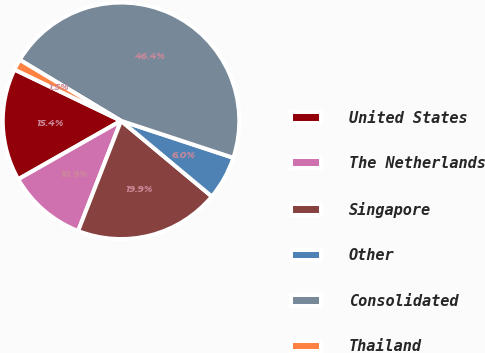<chart> <loc_0><loc_0><loc_500><loc_500><pie_chart><fcel>United States<fcel>The Netherlands<fcel>Singapore<fcel>Other<fcel>Consolidated<fcel>Thailand<nl><fcel>15.36%<fcel>10.86%<fcel>19.85%<fcel>5.99%<fcel>46.44%<fcel>1.49%<nl></chart> 